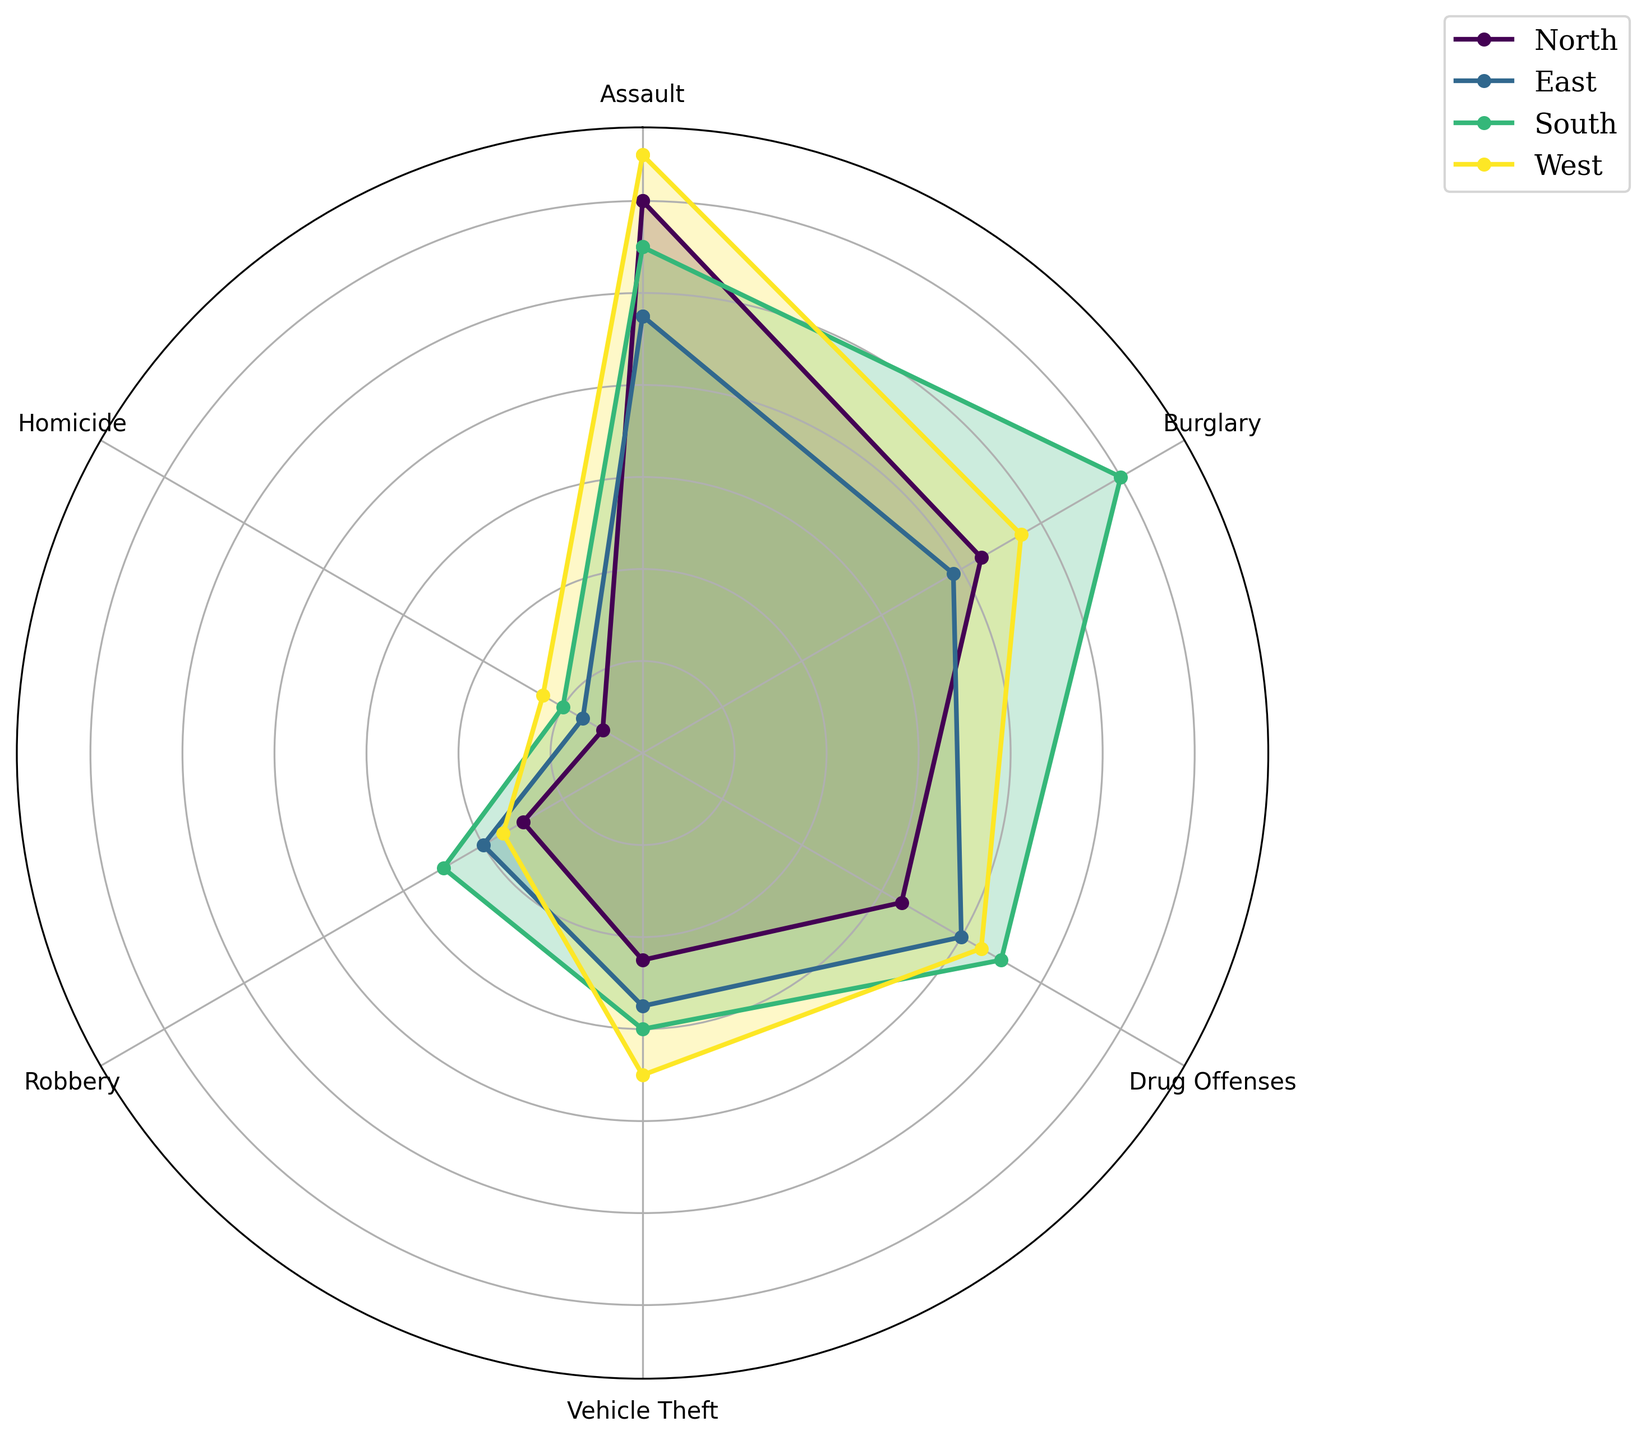Which region has the highest number of assaults? Observe the radial distance for the 'Assault' category for each region. The region with the longest bar segment represents the highest number.
Answer: West In which regions is the number of homicides less than 20? Check the radial distance for the 'Homicide' category. Bars shorter than the reference count of 20 are considered.
Answer: North, East Compare the total crime counts for 'Burglary' in the North and South regions. Which region has a higher count? Review the radial distances for 'Burglary' in the North and South regions and match them with the legend.
Answer: South Which crime type has the most uniform count across all regions? Look for the category where the bar lengths for all regions are similar.
Answer: Assault In which region do drug offenses account for the highest count when compared to other regions? Compare the radial distances of 'Drug Offenses' for all regions to determine which is the longest.
Answer: South What's the difference in the number of vehicle thefts between the East and West regions? Find the radial distances for 'Vehicle Theft' in both the East and West, subtract the smaller count from the larger count.
Answer: 15 Which region has the lowest count of robberies? Identify the radial distance for the 'Robbery' category that is shortest among all regions.
Answer: North How do burglary counts in the North compare with drug offense counts in the South? Examine the radial distances of 'Burglary' in the North and 'Drug Offenses' in the South to see which is longer.
Answer: South has higher Which crime type shows the greatest variance in counts between the North and West regions? Compare differences in bar lengths for each crime type between the North and West and identify the largest difference.
Answer: Assault In which region is the crime type "Vehicle Theft" very close in count to "Robbery"? Compare the radial distances for 'Vehicle Theft' and 'Robbery' categories within each region to find close matches.
Answer: East 